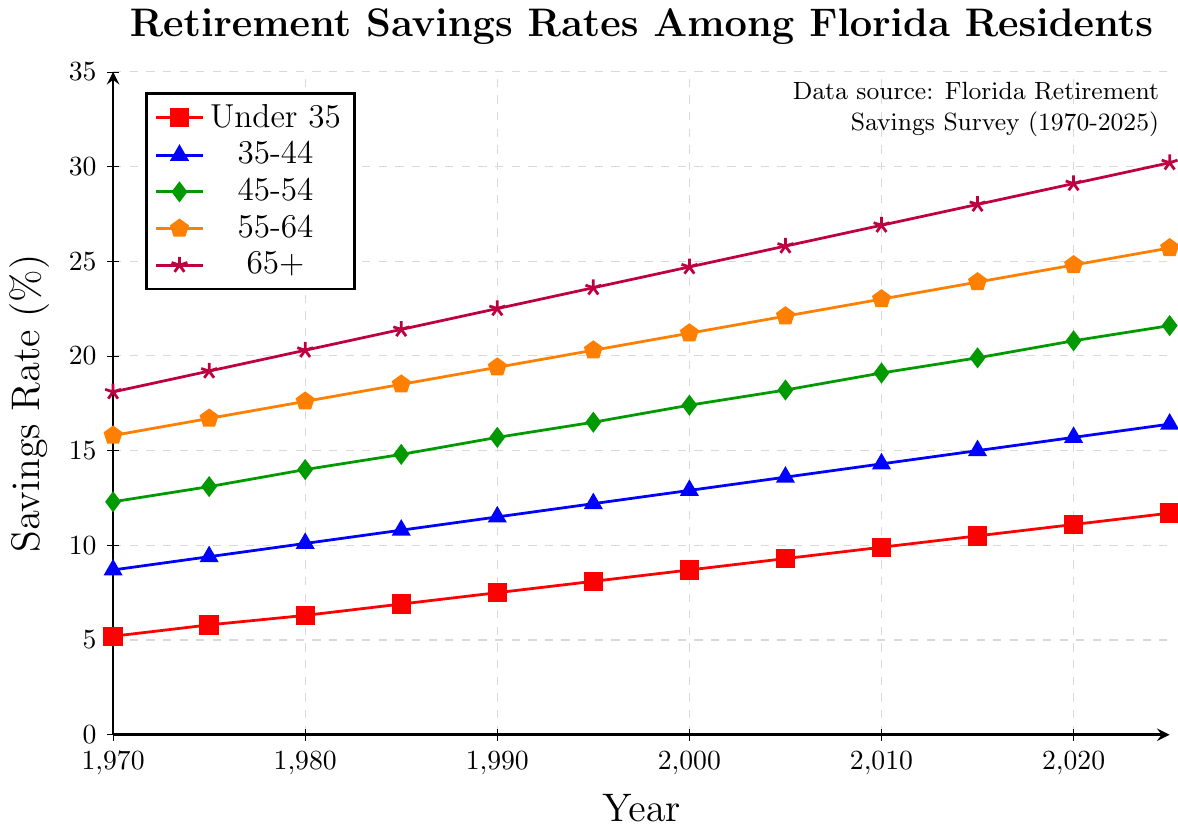When did the savings rate for the 'Under 35' age group first exceed 10%? Find the 'Under 35' plot (red squares) and track the values up to 10%. This first occurs in 2015.
Answer: 2015 Which age group had the highest savings rate in 1970? Check the starting values for each group in 1970 and compare. The group '65+' (purple star) had the highest at 18.1%.
Answer: 65+ How much did the savings rate for the '55-64' age group increase from 1970 to 2025? Subtract the 1970 value for the '55-64' group (15.8%) from the 2025 value (25.7%). The increase is 25.7 - 15.8 = 9.9%.
Answer: 9.9% In which year did the '35-44' age group surpass a savings rate of 15%? Track the '35-44' plot (blue triangles) for values exceeding 15%. This occurs in 2015.
Answer: 2015 How does the savings rate for the '45-54' age group in 1990 compare to the 'Under 35' age group in the same year? Compare the 1990 value for '45-54' (15.7%) to 'Under 35' (7.5%). The '45-54' group has a higher rate.
Answer: '45-54' is higher What was the average savings rate for the '45-54' age group in 2020 and 2025? Sum the values for the '45-54' group in 2020 (20.8%) and 2025 (21.6%) and divide the result by 2. The average is (20.8 + 21.6) / 2 = 21.2%.
Answer: 21.2% Which age group had the smallest increase in savings rate from 2000 to 2025? Calculate the increase for each group and compare: 'Under 35': 11.7 - 8.7 = 3.0%, '35-44': 16.4 - 12.9 = 3.5%, '45-54': 21.6 - 17.4 = 4.2%, '55-64': 25.7 - 21.2 = 4.5%, '65+': 30.2 - 24.7 = 5.5%. The 'Under 35' group has the smallest increase.
Answer: 'Under 35' What is the difference in the 2025 savings rate between the '65+' and '45-54' age groups? Subtract the 2025 value for '45-54' (21.6%) from '65+' (30.2%). The difference is 30.2 - 21.6 = 8.6%.
Answer: 8.6% How did the '35-44' and '55-64' age groups' savings rates compare in 1980? Compare the 1980 values for '35-44' (10.1%) and '55-64' (17.6%). The '55-64' group has a higher rate.
Answer: '55-64' is higher Which age group shows a continuous increase in savings rates without any dips from 1970 to 2025? By observing each age group's plot, the 'Under 35' (red squares) shows a continuous rise without any dips.
Answer: 'Under 35' 